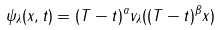<formula> <loc_0><loc_0><loc_500><loc_500>\psi _ { \lambda } ( x , t ) = ( T - t ) ^ { \alpha } v _ { \lambda } ( ( T - t ) ^ { \beta } x )</formula> 